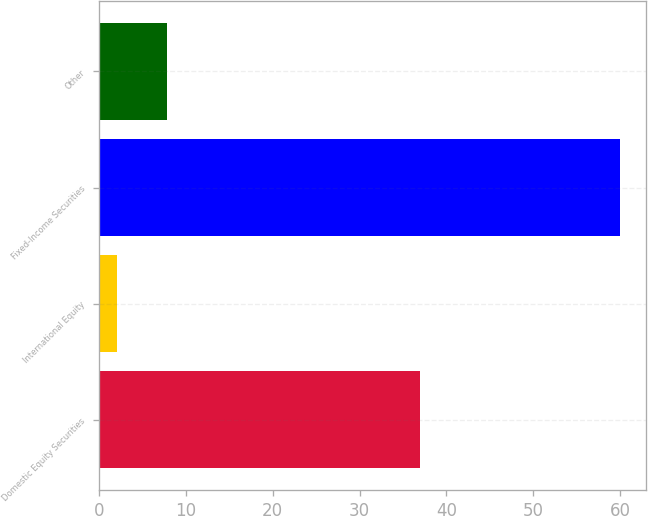Convert chart to OTSL. <chart><loc_0><loc_0><loc_500><loc_500><bar_chart><fcel>Domestic Equity Securities<fcel>International Equity<fcel>Fixed-Income Securities<fcel>Other<nl><fcel>37<fcel>2.05<fcel>60<fcel>7.85<nl></chart> 